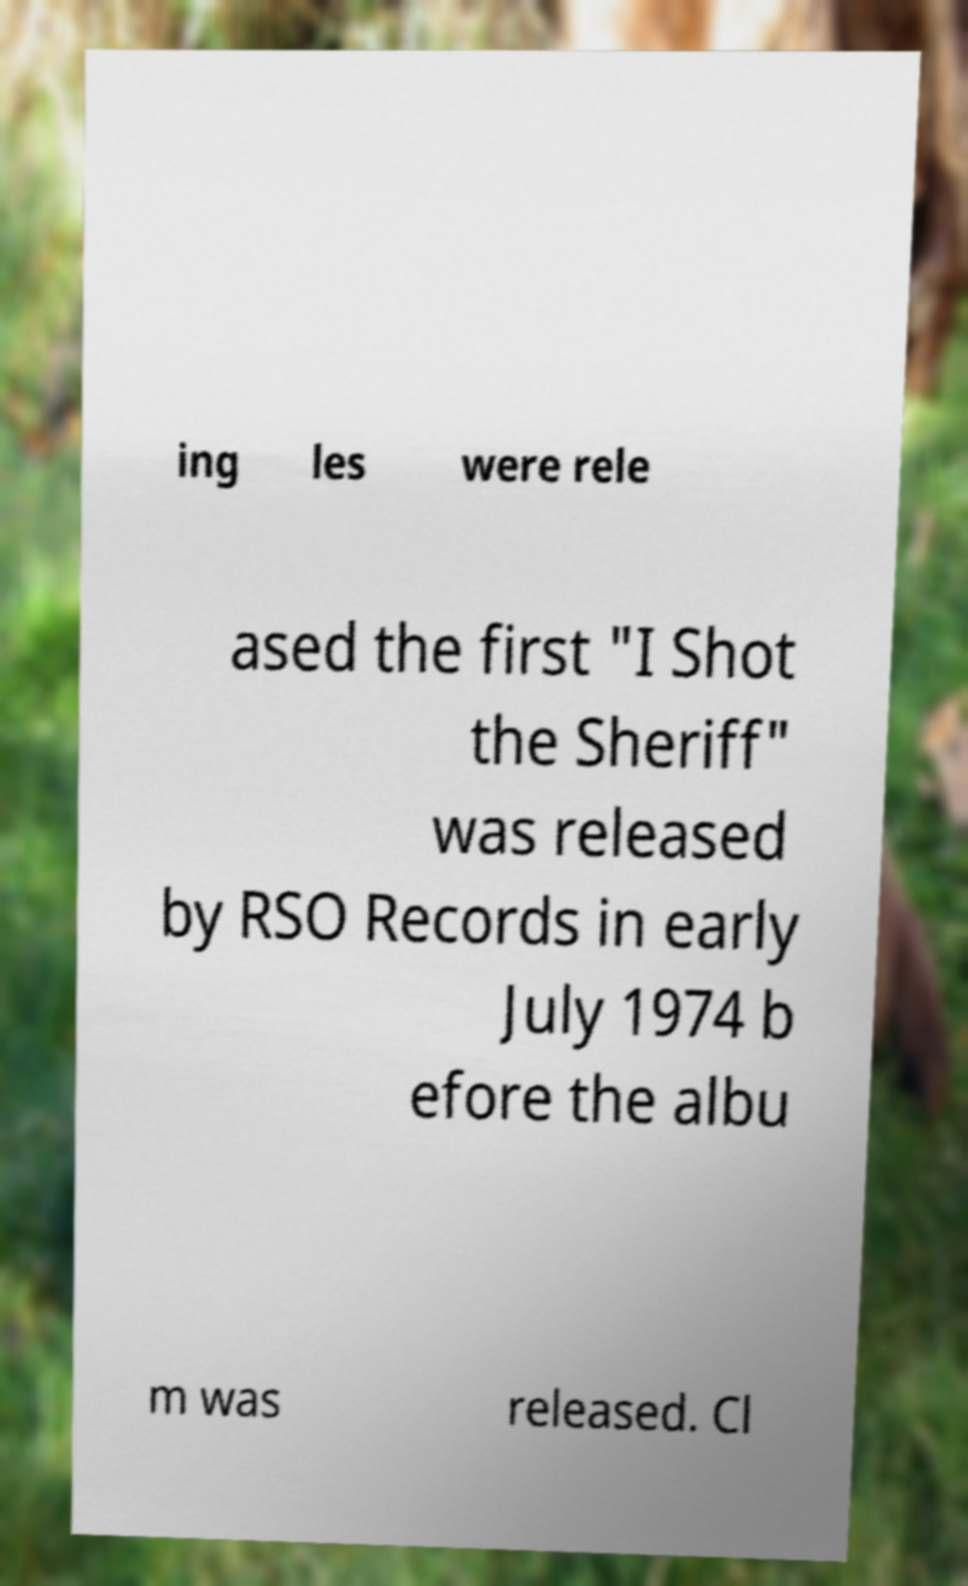Could you extract and type out the text from this image? ing les were rele ased the first "I Shot the Sheriff" was released by RSO Records in early July 1974 b efore the albu m was released. Cl 